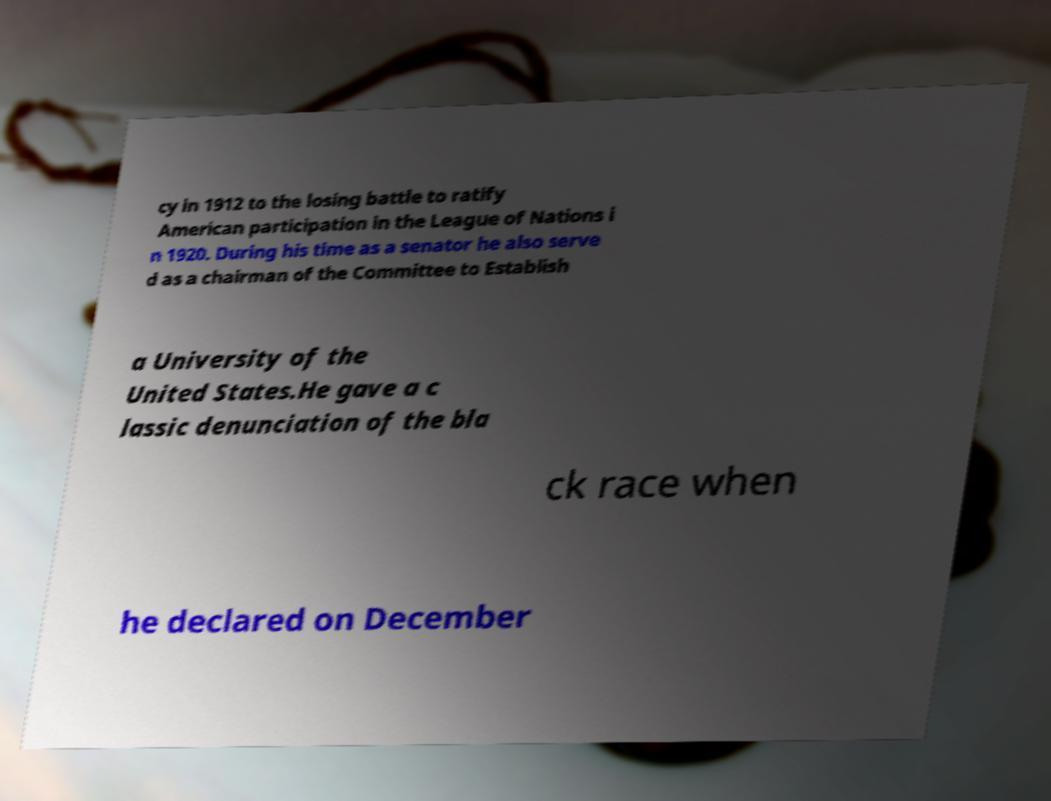Can you accurately transcribe the text from the provided image for me? cy in 1912 to the losing battle to ratify American participation in the League of Nations i n 1920. During his time as a senator he also serve d as a chairman of the Committee to Establish a University of the United States.He gave a c lassic denunciation of the bla ck race when he declared on December 